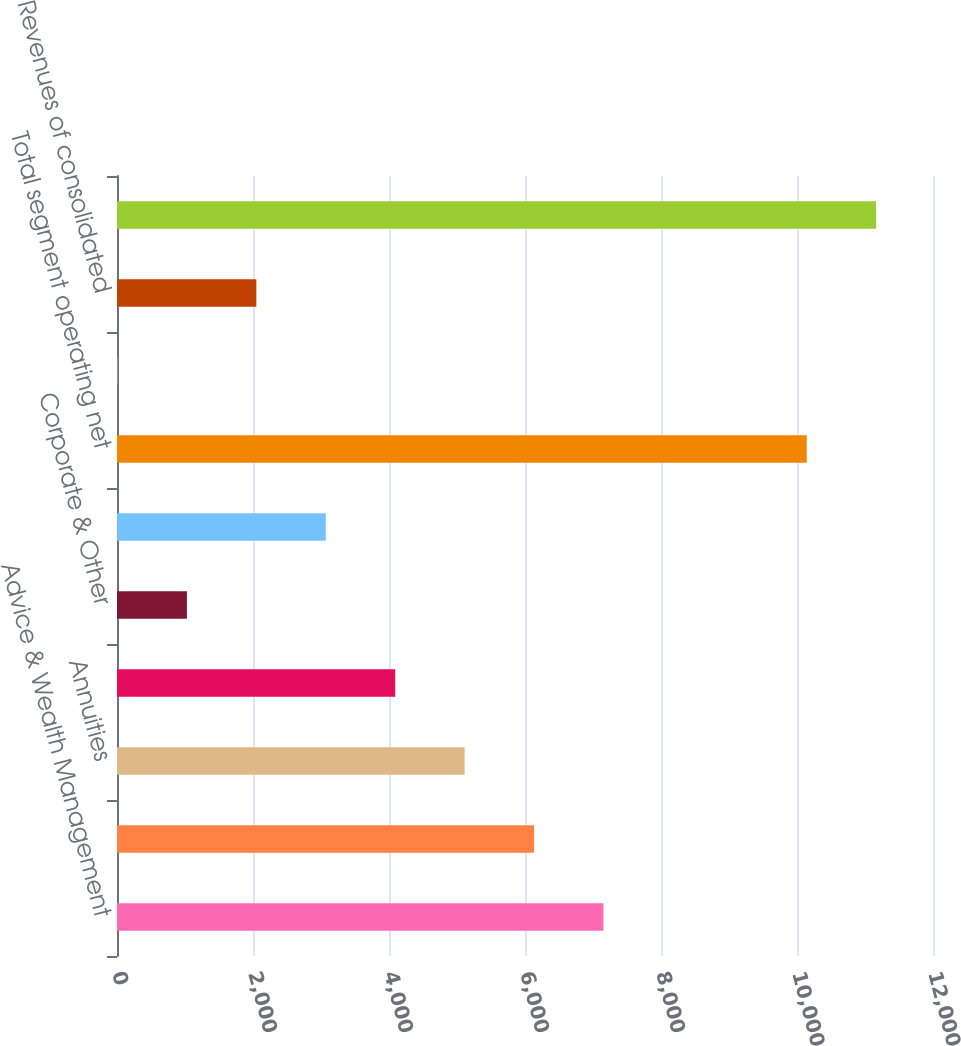Convert chart. <chart><loc_0><loc_0><loc_500><loc_500><bar_chart><fcel>Advice & Wealth Management<fcel>Asset Management<fcel>Annuities<fcel>Protection<fcel>Corporate & Other<fcel>Eliminations (1)<fcel>Total segment operating net<fcel>Net realized gains<fcel>Revenues of consolidated<fcel>Total net revenues per<nl><fcel>7154<fcel>6133<fcel>5112<fcel>4091<fcel>1028<fcel>3070<fcel>10143<fcel>7<fcel>2049<fcel>11164<nl></chart> 